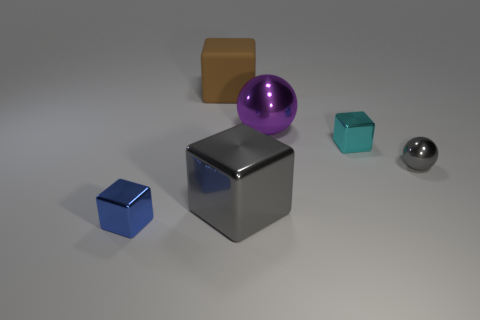Is there anything else that has the same material as the large brown thing?
Provide a succinct answer. No. How many things are big purple metal spheres in front of the big matte block or tiny shiny cubes that are left of the gray cube?
Make the answer very short. 2. Are there any other things of the same color as the big metal ball?
Make the answer very short. No. There is a small shiny cube that is in front of the tiny cube that is behind the gray thing right of the big purple metal ball; what color is it?
Ensure brevity in your answer.  Blue. There is a metallic cube that is behind the shiny ball in front of the big metallic ball; what size is it?
Offer a very short reply. Small. What is the material of the block that is on the left side of the big gray metal cube and behind the large gray metallic thing?
Your answer should be compact. Rubber. There is a matte thing; does it have the same size as the gray object that is to the left of the big purple metallic object?
Keep it short and to the point. Yes. Are any metallic cylinders visible?
Your response must be concise. No. What is the material of the brown object that is the same shape as the cyan shiny thing?
Offer a very short reply. Rubber. What is the size of the block that is in front of the gray metal cube on the left side of the block on the right side of the big purple ball?
Give a very brief answer. Small. 